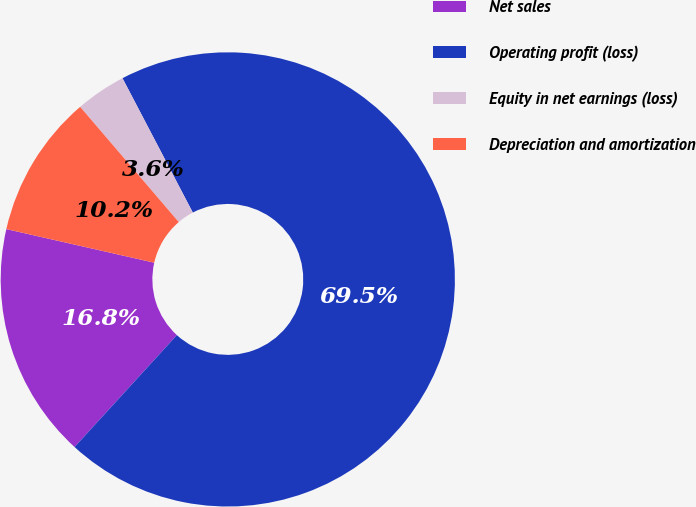Convert chart to OTSL. <chart><loc_0><loc_0><loc_500><loc_500><pie_chart><fcel>Net sales<fcel>Operating profit (loss)<fcel>Equity in net earnings (loss)<fcel>Depreciation and amortization<nl><fcel>16.77%<fcel>69.46%<fcel>3.59%<fcel>10.18%<nl></chart> 